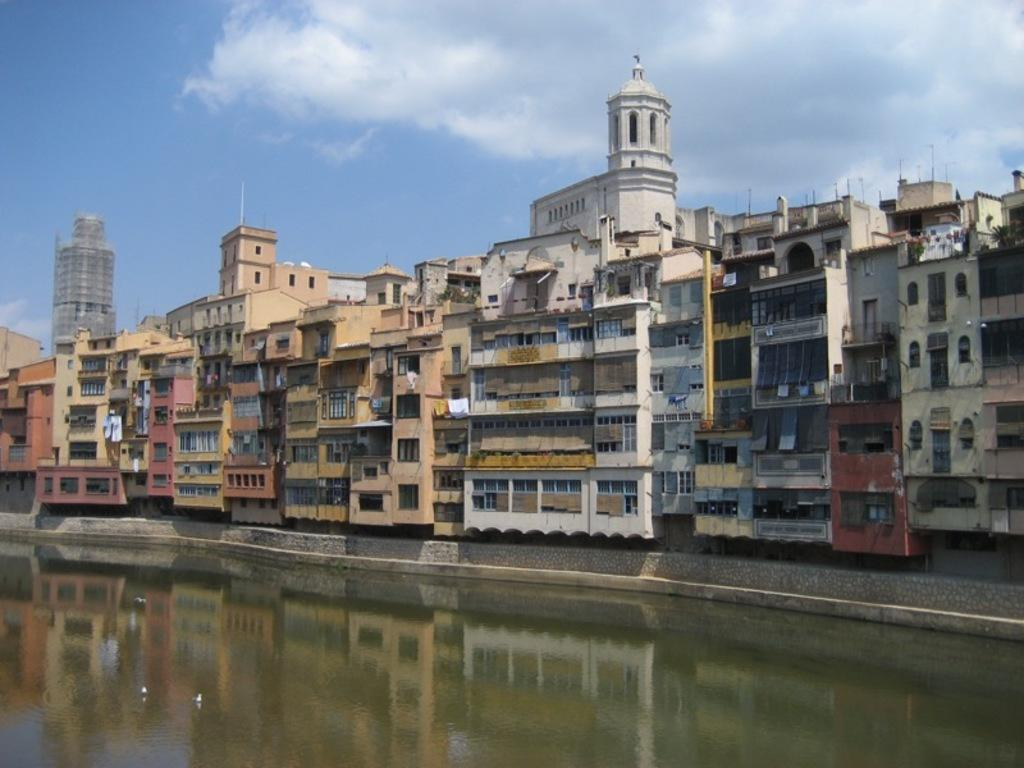What is the primary element visible in the image? There is water in the image. What type of structures can be seen in the image? There are buildings in the image. What architectural feature is present in the image? There is a wall in the image. What can be seen on the wall in the image? There are windows in the image. What other objects are present in the image? There are poles in the image. What is visible in the background of the image? The sky is visible in the background of the image, and clouds are present in the sky. What title is written on the pail in the image? There is no pail present in the image, so there is no title to be read. 